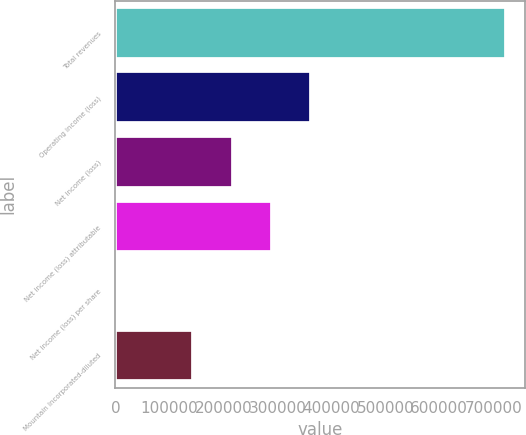Convert chart. <chart><loc_0><loc_0><loc_500><loc_500><bar_chart><fcel>Total revenues<fcel>Operating income (loss)<fcel>Net income (loss)<fcel>Net income (loss) attributable<fcel>Net income (loss) per share<fcel>Mountain Incorporated-diluted<nl><fcel>723346<fcel>361673<fcel>217004<fcel>289338<fcel>0.12<fcel>144669<nl></chart> 